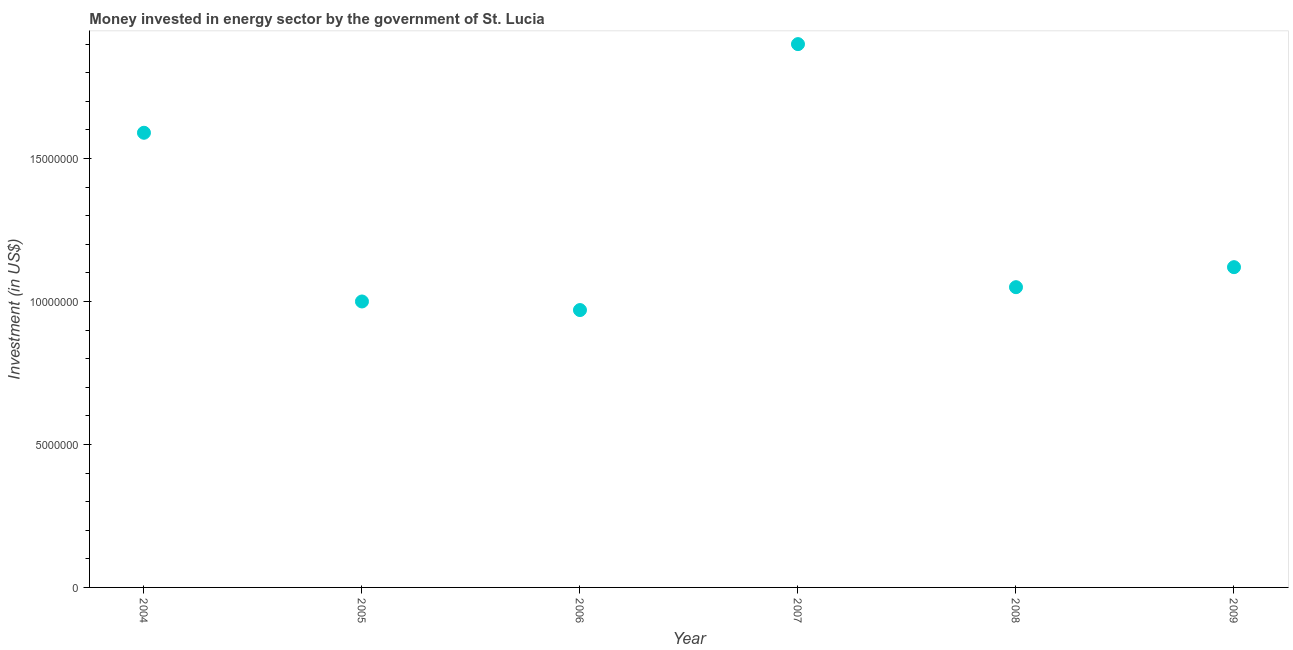What is the investment in energy in 2004?
Your answer should be compact. 1.59e+07. Across all years, what is the maximum investment in energy?
Your answer should be very brief. 1.90e+07. Across all years, what is the minimum investment in energy?
Provide a succinct answer. 9.70e+06. What is the sum of the investment in energy?
Your answer should be compact. 7.63e+07. What is the difference between the investment in energy in 2005 and 2008?
Keep it short and to the point. -5.00e+05. What is the average investment in energy per year?
Your answer should be very brief. 1.27e+07. What is the median investment in energy?
Your answer should be very brief. 1.08e+07. In how many years, is the investment in energy greater than 12000000 US$?
Keep it short and to the point. 2. Do a majority of the years between 2009 and 2006 (inclusive) have investment in energy greater than 10000000 US$?
Your answer should be very brief. Yes. What is the ratio of the investment in energy in 2004 to that in 2007?
Your answer should be very brief. 0.84. What is the difference between the highest and the second highest investment in energy?
Give a very brief answer. 3.10e+06. What is the difference between the highest and the lowest investment in energy?
Your response must be concise. 9.30e+06. Does the investment in energy monotonically increase over the years?
Your answer should be compact. No. What is the difference between two consecutive major ticks on the Y-axis?
Keep it short and to the point. 5.00e+06. Are the values on the major ticks of Y-axis written in scientific E-notation?
Your answer should be very brief. No. Does the graph contain any zero values?
Give a very brief answer. No. What is the title of the graph?
Provide a succinct answer. Money invested in energy sector by the government of St. Lucia. What is the label or title of the X-axis?
Your answer should be very brief. Year. What is the label or title of the Y-axis?
Your answer should be compact. Investment (in US$). What is the Investment (in US$) in 2004?
Give a very brief answer. 1.59e+07. What is the Investment (in US$) in 2005?
Offer a terse response. 1.00e+07. What is the Investment (in US$) in 2006?
Your answer should be compact. 9.70e+06. What is the Investment (in US$) in 2007?
Offer a very short reply. 1.90e+07. What is the Investment (in US$) in 2008?
Your answer should be very brief. 1.05e+07. What is the Investment (in US$) in 2009?
Keep it short and to the point. 1.12e+07. What is the difference between the Investment (in US$) in 2004 and 2005?
Your answer should be compact. 5.90e+06. What is the difference between the Investment (in US$) in 2004 and 2006?
Your response must be concise. 6.20e+06. What is the difference between the Investment (in US$) in 2004 and 2007?
Make the answer very short. -3.10e+06. What is the difference between the Investment (in US$) in 2004 and 2008?
Your response must be concise. 5.40e+06. What is the difference between the Investment (in US$) in 2004 and 2009?
Provide a short and direct response. 4.70e+06. What is the difference between the Investment (in US$) in 2005 and 2007?
Give a very brief answer. -9.00e+06. What is the difference between the Investment (in US$) in 2005 and 2008?
Your answer should be very brief. -5.00e+05. What is the difference between the Investment (in US$) in 2005 and 2009?
Your response must be concise. -1.20e+06. What is the difference between the Investment (in US$) in 2006 and 2007?
Give a very brief answer. -9.30e+06. What is the difference between the Investment (in US$) in 2006 and 2008?
Your answer should be compact. -8.00e+05. What is the difference between the Investment (in US$) in 2006 and 2009?
Provide a succinct answer. -1.50e+06. What is the difference between the Investment (in US$) in 2007 and 2008?
Ensure brevity in your answer.  8.50e+06. What is the difference between the Investment (in US$) in 2007 and 2009?
Provide a succinct answer. 7.80e+06. What is the difference between the Investment (in US$) in 2008 and 2009?
Provide a succinct answer. -7.00e+05. What is the ratio of the Investment (in US$) in 2004 to that in 2005?
Give a very brief answer. 1.59. What is the ratio of the Investment (in US$) in 2004 to that in 2006?
Your answer should be very brief. 1.64. What is the ratio of the Investment (in US$) in 2004 to that in 2007?
Make the answer very short. 0.84. What is the ratio of the Investment (in US$) in 2004 to that in 2008?
Offer a terse response. 1.51. What is the ratio of the Investment (in US$) in 2004 to that in 2009?
Ensure brevity in your answer.  1.42. What is the ratio of the Investment (in US$) in 2005 to that in 2006?
Keep it short and to the point. 1.03. What is the ratio of the Investment (in US$) in 2005 to that in 2007?
Give a very brief answer. 0.53. What is the ratio of the Investment (in US$) in 2005 to that in 2009?
Your answer should be compact. 0.89. What is the ratio of the Investment (in US$) in 2006 to that in 2007?
Your response must be concise. 0.51. What is the ratio of the Investment (in US$) in 2006 to that in 2008?
Your response must be concise. 0.92. What is the ratio of the Investment (in US$) in 2006 to that in 2009?
Your answer should be very brief. 0.87. What is the ratio of the Investment (in US$) in 2007 to that in 2008?
Keep it short and to the point. 1.81. What is the ratio of the Investment (in US$) in 2007 to that in 2009?
Make the answer very short. 1.7. What is the ratio of the Investment (in US$) in 2008 to that in 2009?
Make the answer very short. 0.94. 